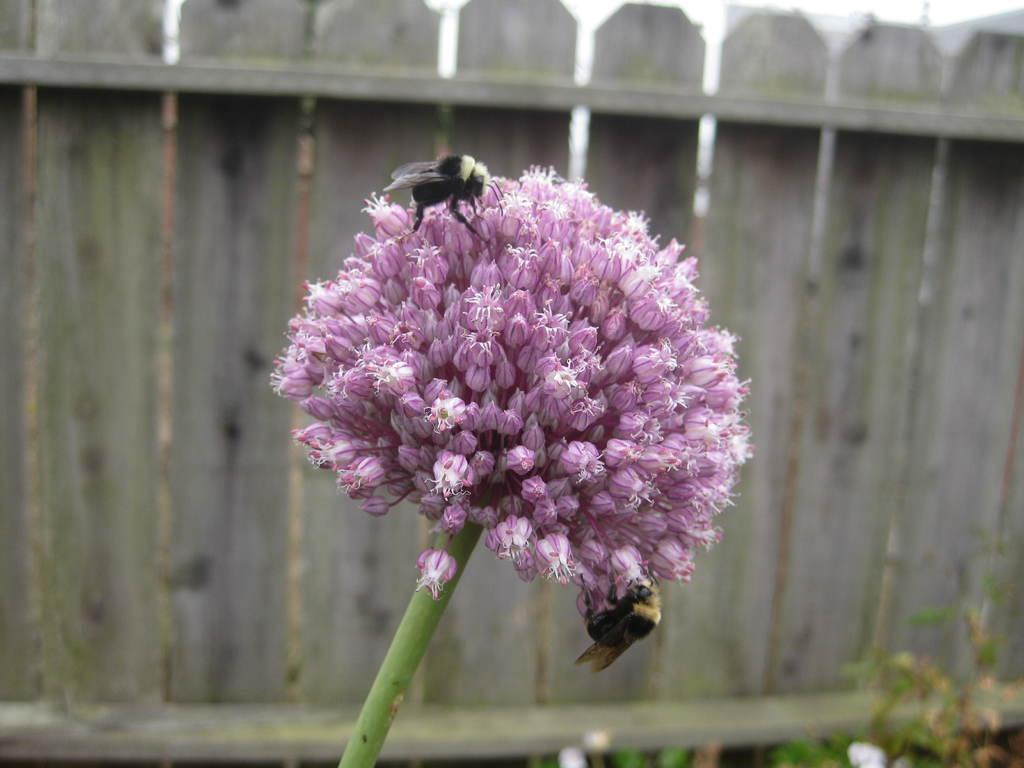What is the main subject in the middle of the image? There is a flower in the middle of the image. What other living organisms can be seen in the image? Insects are present in the image. What type of structure can be seen in the background of the image? There is a wooden fence in the background of the image. What type of vegetation is visible in the background of the image? Plants are visible in the background of the image. What type of whip can be seen in the image? There is no whip present in the image. How does the flower form in the image? The flower is already formed in the image; it does not show the process of forming. 